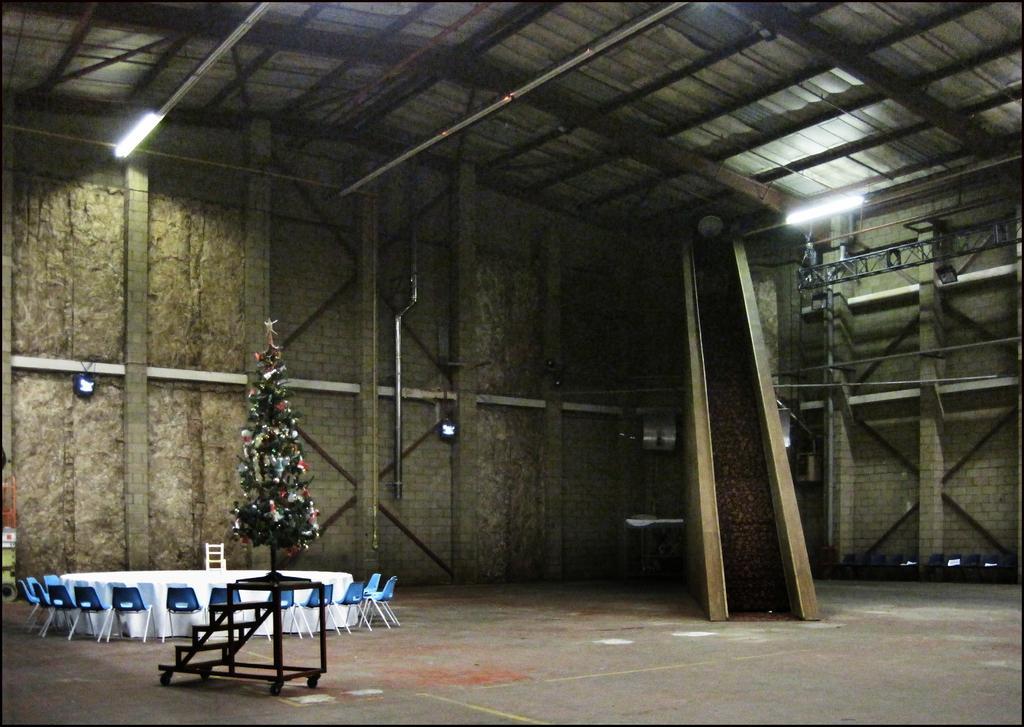Can you describe this image briefly? There is a light at the top. It's a Christmas tree behind this there is a table and chairs. 